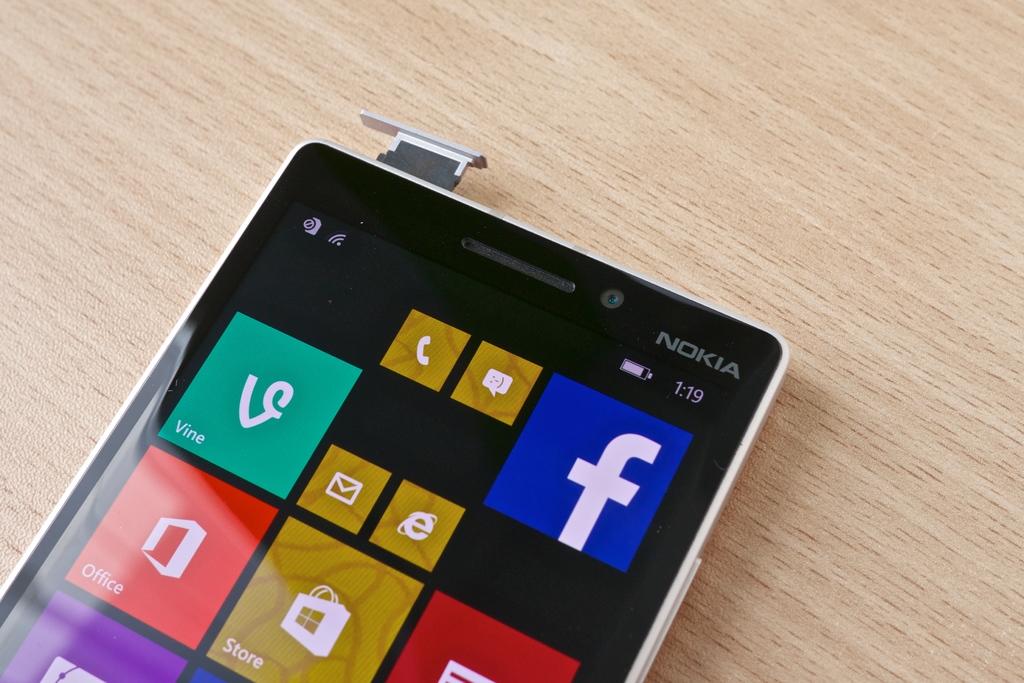What brand of cell phone is this?
Make the answer very short. Nokia. What app is on top right corner?
Your response must be concise. Facebook. 